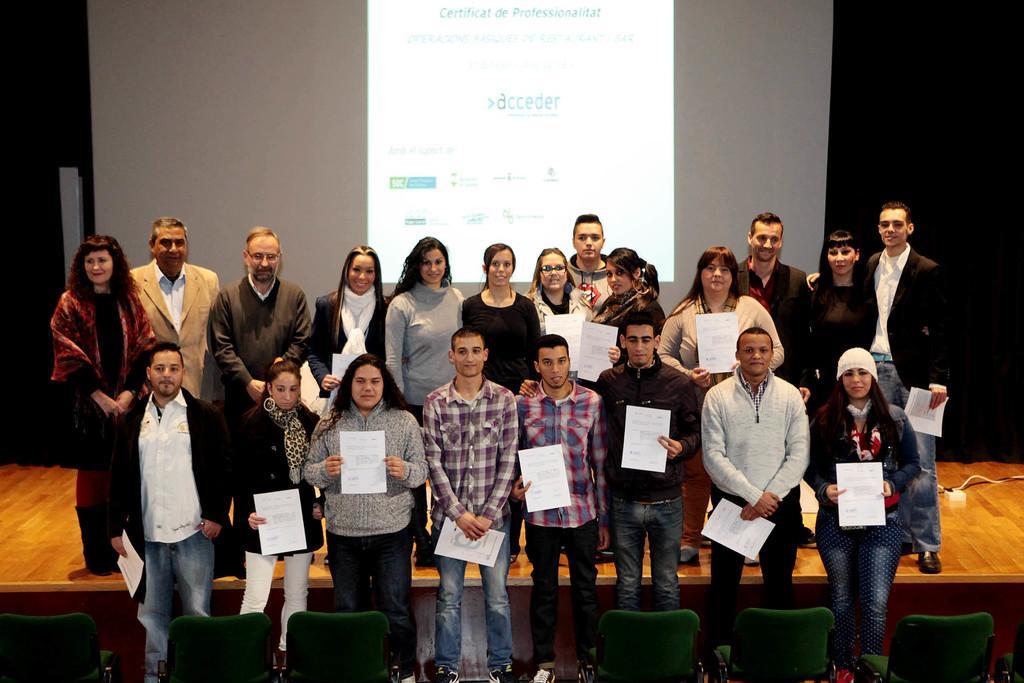Please provide a concise description of this image. In the center of the image we can see people standing and holding papers in their hands. At the bottom there are chairs. In the background there is a screen and curtains. 